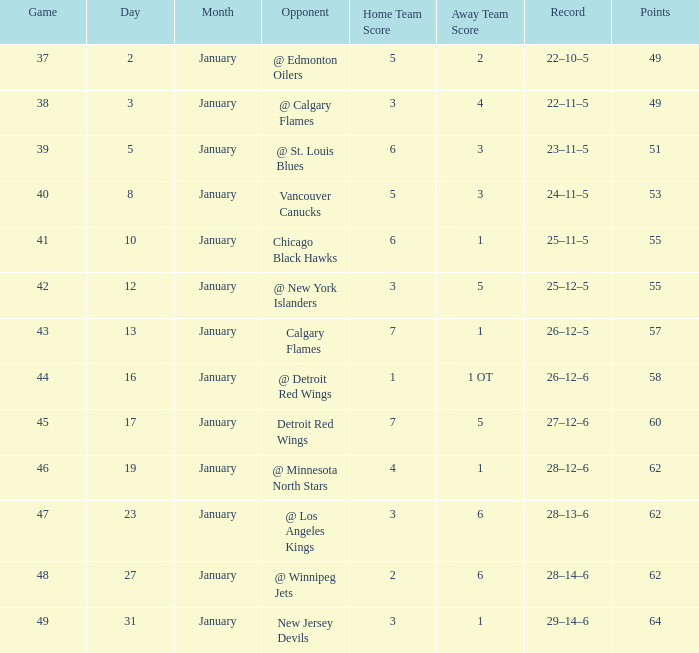How many Games have a Score of 2–6, and Points larger than 62? 0.0. 